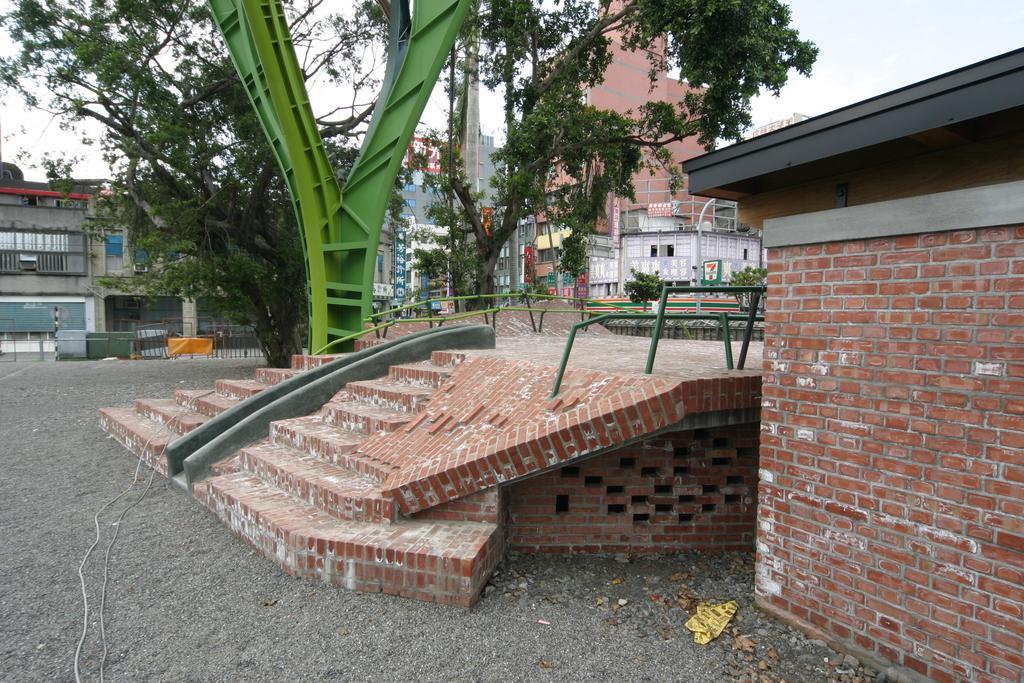Please provide a concise description of this image. This is an outside view. On the right side there is a wall. In the middle of the image there is a stage and I can see the stairs. In the background there are some trees and buildings. At the top of the image I can see the sky. 